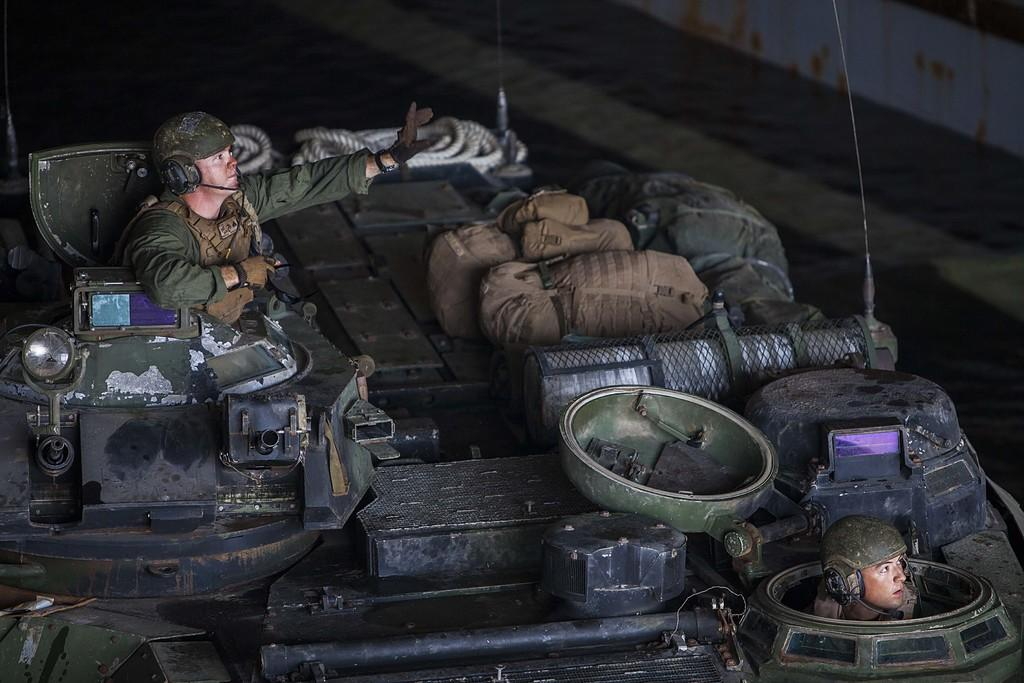How many people are in the image? There are two people in the image. What are the people wearing? The people are wearing army dresses and helmets. What can be seen in the image besides the people? There is a rope and bags in the image. How would you describe the lighting in the image? The image is slightly dark. What type of truck can be seen in the image? There is no truck present in the image. How much debt do the people in the image have? There is no information about the people's debt in the image. 